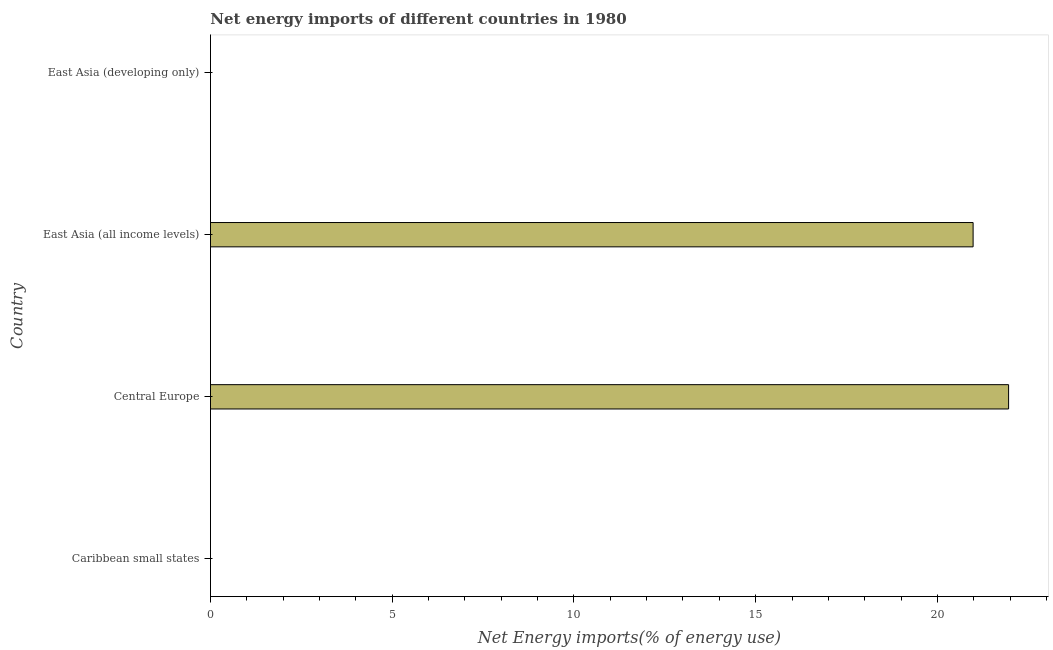Does the graph contain any zero values?
Give a very brief answer. Yes. Does the graph contain grids?
Provide a short and direct response. No. What is the title of the graph?
Your answer should be compact. Net energy imports of different countries in 1980. What is the label or title of the X-axis?
Your answer should be very brief. Net Energy imports(% of energy use). Across all countries, what is the maximum energy imports?
Give a very brief answer. 21.96. In which country was the energy imports maximum?
Your answer should be compact. Central Europe. What is the sum of the energy imports?
Your answer should be very brief. 42.94. What is the difference between the energy imports in Central Europe and East Asia (all income levels)?
Make the answer very short. 0.98. What is the average energy imports per country?
Make the answer very short. 10.73. What is the median energy imports?
Your answer should be very brief. 10.49. What is the ratio of the energy imports in Central Europe to that in East Asia (all income levels)?
Offer a terse response. 1.05. Is the energy imports in Central Europe less than that in East Asia (all income levels)?
Your response must be concise. No. What is the difference between the highest and the lowest energy imports?
Your answer should be very brief. 21.96. In how many countries, is the energy imports greater than the average energy imports taken over all countries?
Give a very brief answer. 2. How many bars are there?
Provide a short and direct response. 2. What is the difference between two consecutive major ticks on the X-axis?
Your answer should be compact. 5. What is the Net Energy imports(% of energy use) of Caribbean small states?
Provide a succinct answer. 0. What is the Net Energy imports(% of energy use) in Central Europe?
Your answer should be compact. 21.96. What is the Net Energy imports(% of energy use) of East Asia (all income levels)?
Your response must be concise. 20.98. What is the Net Energy imports(% of energy use) in East Asia (developing only)?
Provide a short and direct response. 0. What is the difference between the Net Energy imports(% of energy use) in Central Europe and East Asia (all income levels)?
Ensure brevity in your answer.  0.98. What is the ratio of the Net Energy imports(% of energy use) in Central Europe to that in East Asia (all income levels)?
Offer a terse response. 1.05. 